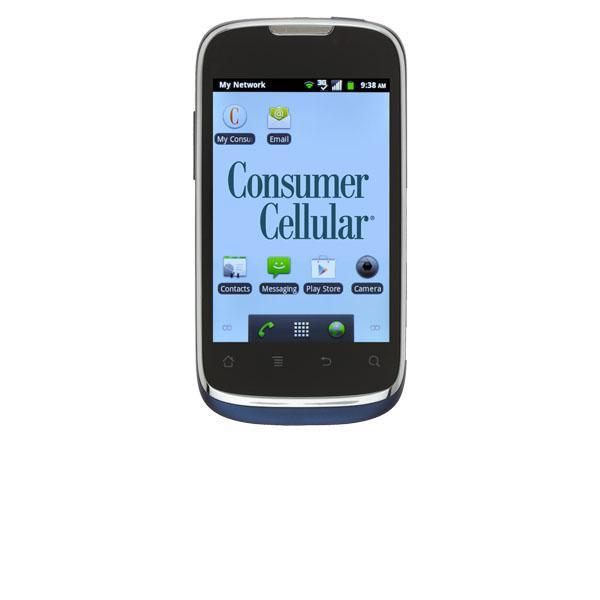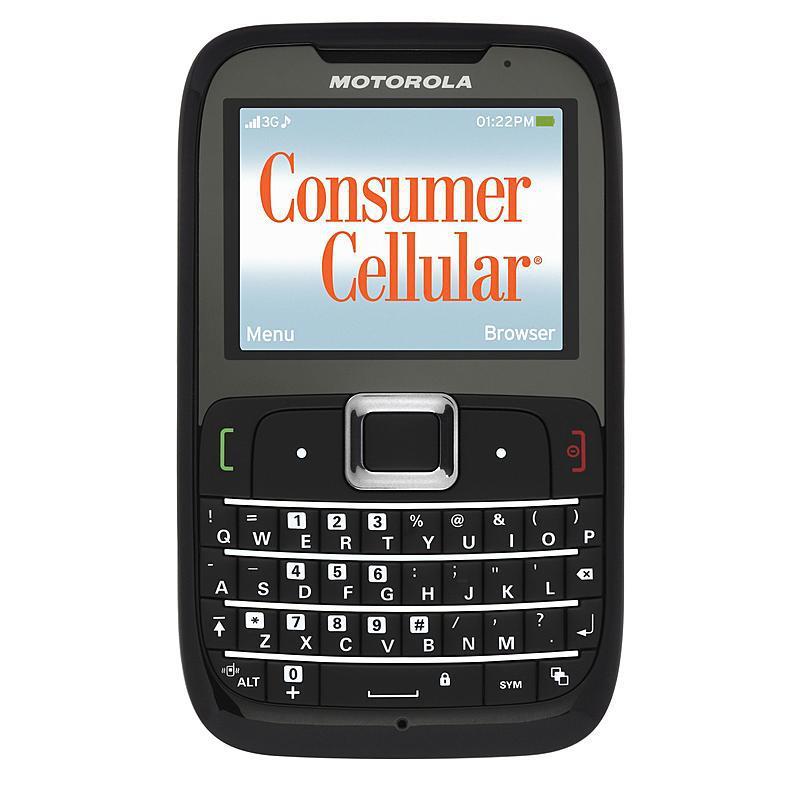The first image is the image on the left, the second image is the image on the right. Given the left and right images, does the statement "The cellphone in each image shows the Google search bar on it's home page." hold true? Answer yes or no. No. 